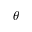Convert formula to latex. <formula><loc_0><loc_0><loc_500><loc_500>\theta</formula> 